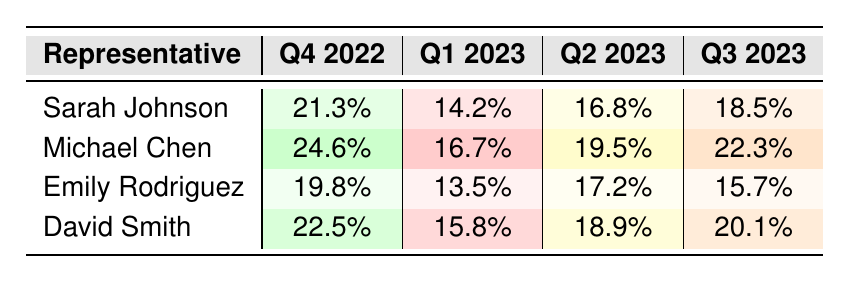What is the revenue growth percentage for Michael Chen in Q3 2023? Michael Chen's revenue growth percentage in Q3 2023 is listed in the table. I can find this under the "Q3 2023" column corresponding to Michael Chen's row. The value is 22.3%.
Answer: 22.3% Which representative had the highest revenue growth percentage in Q2 2023? By checking the Q2 2023 column for each representative, I can see the values: Sarah Johnson (16.8%), Michael Chen (19.5%), Emily Rodriguez (17.2%), and David Smith (18.9%). The highest is Michael Chen at 19.5%.
Answer: Michael Chen What is the difference in revenue growth percentage between David Smith in Q4 2022 and Q1 2023? In the Q4 2022 column, David Smith has a revenue growth percentage of 22.5%, while in Q1 2023, it is 15.8%. The difference is calculated as 22.5% - 15.8% = 6.7%.
Answer: 6.7% What is the average revenue growth percentage for Sarah Johnson across all quarters? The relevant percentages for Sarah Johnson are: 21.3% (Q4 2022), 14.2% (Q1 2023), 16.8% (Q2 2023), and 18.5% (Q3 2023). Summing these gives 21.3 + 14.2 + 16.8 + 18.5 = 70.8%. Dividing by 4 gives an average of 70.8% / 4 = 17.7%.
Answer: 17.7% Did Emily Rodriguez ever exceed 18% in revenue growth percentage? To answer this, I need to check Emily Rodriguez's percentages in all quarters: 19.8% (Q4 2022), 13.5% (Q1 2023), 17.2% (Q2 2023), and 15.7% (Q3 2023). She exceeded 18% in Q4 2022.
Answer: Yes Which representative showed the most consistent growth across quarters based on the percentages? To identify this, I will look at how much the revenue growth percentage varies for each representative. For Sarah Johnson: (21.3, 14.2, 16.8, 18.5) variance; Michael Chen: (24.6, 16.7, 19.5, 22.3) variance; Emily Rodriguez: (19.8, 13.5, 17.2, 15.7) variance; David Smith: (22.5, 15.8, 18.9, 20.1) variance. I will calculate the ranges: Sarah = 21.3 - 14.2 = 7.1, Michael = 24.6 - 16.7 = 7.9, Emily = 19.8 - 13.5 = 6.3, David = 22.5 - 15.8 = 6.7. Emily Rodriguez had the smallest range (6.3), indicating she was the most consistent.
Answer: Emily Rodriguez What are the two quarters in which Michael Chen performed above 20%? Looking at Michael Chen’s results in the table, the quarters with percentages are: Q4 2022 (24.6%) and Q3 2023 (22.3%).
Answer: Q4 2022 and Q3 2023 